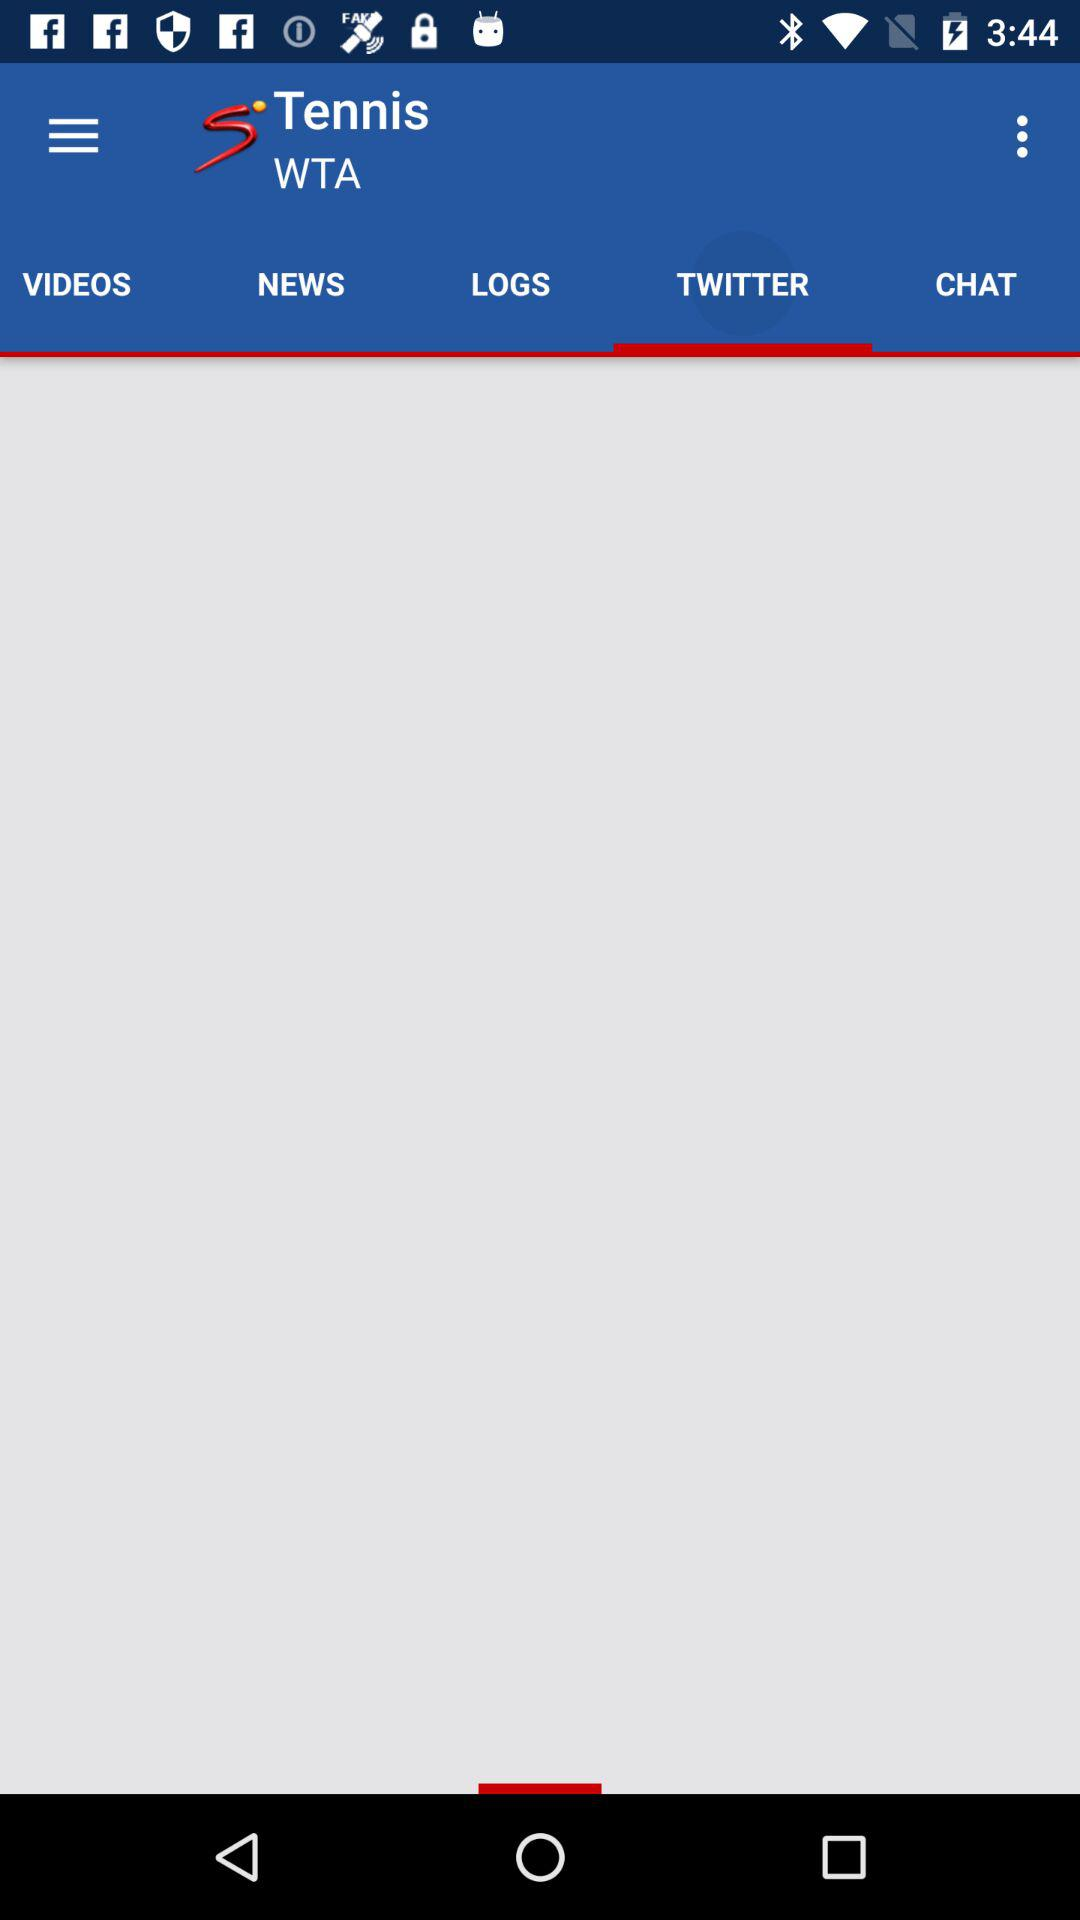What is the application name? The application name is "SuperSport". 